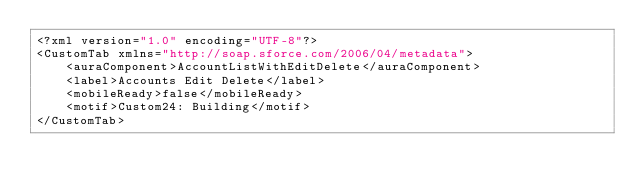Convert code to text. <code><loc_0><loc_0><loc_500><loc_500><_SQL_><?xml version="1.0" encoding="UTF-8"?>
<CustomTab xmlns="http://soap.sforce.com/2006/04/metadata">
    <auraComponent>AccountListWithEditDelete</auraComponent>
    <label>Accounts Edit Delete</label>
    <mobileReady>false</mobileReady>
    <motif>Custom24: Building</motif>
</CustomTab>
</code> 